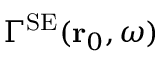<formula> <loc_0><loc_0><loc_500><loc_500>\Gamma ^ { S E } ( { r } _ { 0 } , \omega )</formula> 